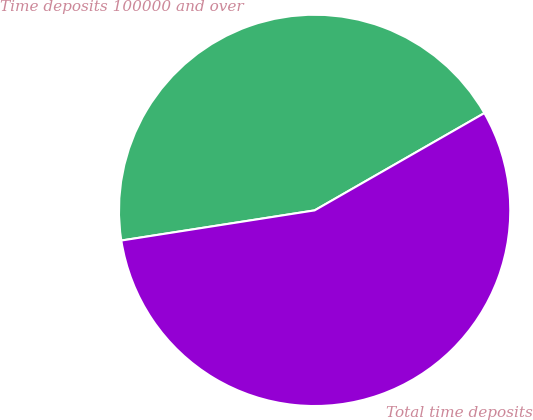Convert chart. <chart><loc_0><loc_0><loc_500><loc_500><pie_chart><fcel>Time deposits 100000 and over<fcel>Total time deposits<nl><fcel>44.18%<fcel>55.82%<nl></chart> 